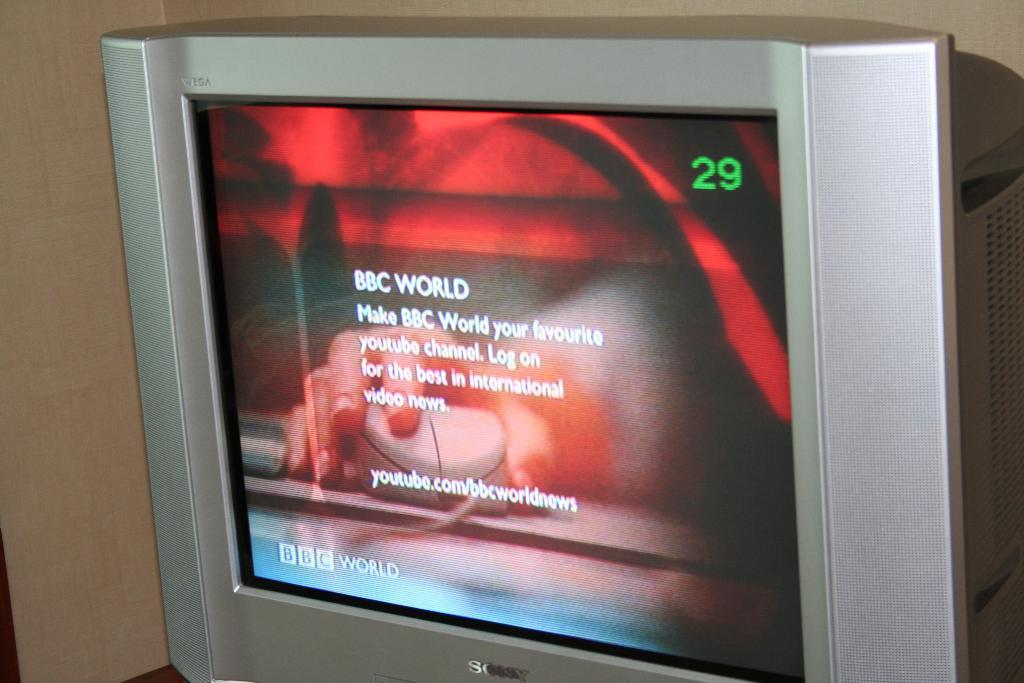<image>
Write a terse but informative summary of the picture. The BBC World news is on TV channel 29. 